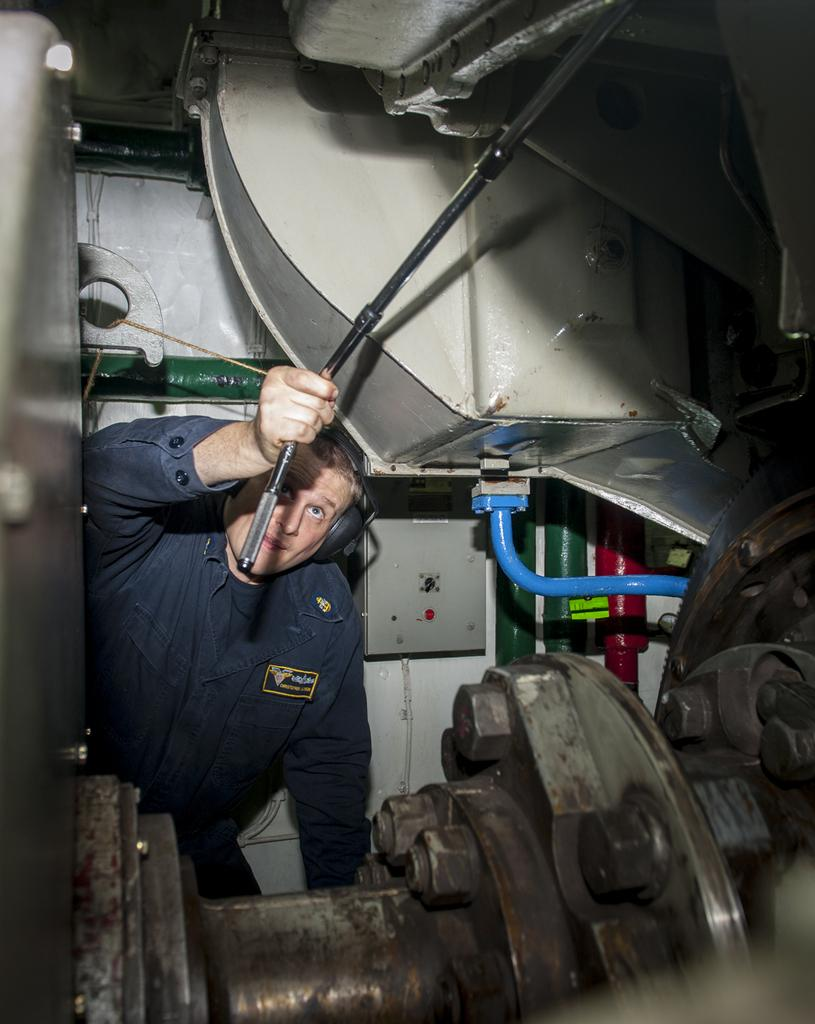What can be seen in the image? There is a person in the image. What is the person wearing? The person is wearing a blue dress. What is the person holding in the image? The person is holding an iron stick. What is the person doing in the image? The person is doing some work near an object. What type of texture can be seen on the calendar in the image? There is no calendar present in the image, so it is not possible to determine the texture of a calendar. 